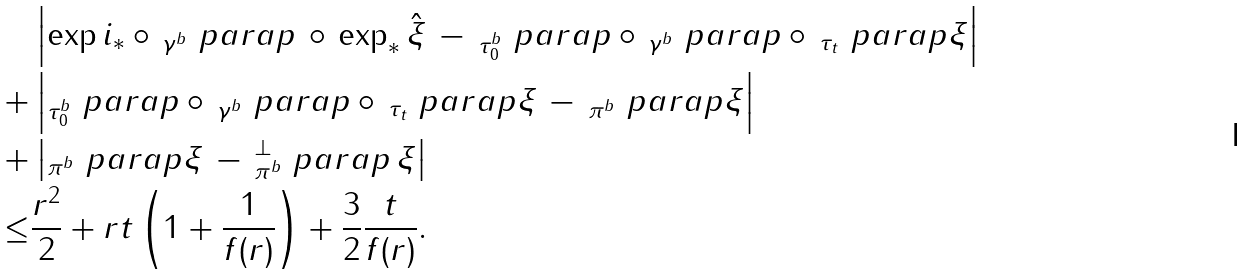<formula> <loc_0><loc_0><loc_500><loc_500>& \left | \exp i _ { * } \circ \, _ { \gamma ^ { b } } \ p a r a p \, \circ \, \exp _ { * } \hat { \xi } \, - \, _ { \tau _ { 0 } ^ { b } } \ p a r a p \circ \, _ { \gamma ^ { b } } \ p a r a p \circ \, _ { \tau _ { t } } \ p a r a p \xi \right | \\ + & \left | _ { \tau _ { 0 } ^ { b } } \ p a r a p \circ \, _ { \gamma ^ { b } } \ p a r a p \circ \, _ { \tau _ { t } } \ p a r a p \xi \, - \, _ { \pi ^ { b } } \ p a r a p \xi \right | \\ + & \left | _ { \pi ^ { b } } \ p a r a p \xi \, - \, _ { \pi ^ { b } } ^ { \perp } \ p a r a p \, \xi \right | \\ \leq & \frac { r ^ { 2 } } { 2 } + r t \left ( 1 + \frac { 1 } { f ( r ) } \right ) + \frac { 3 } { 2 } \frac { t } { f ( r ) } .</formula> 